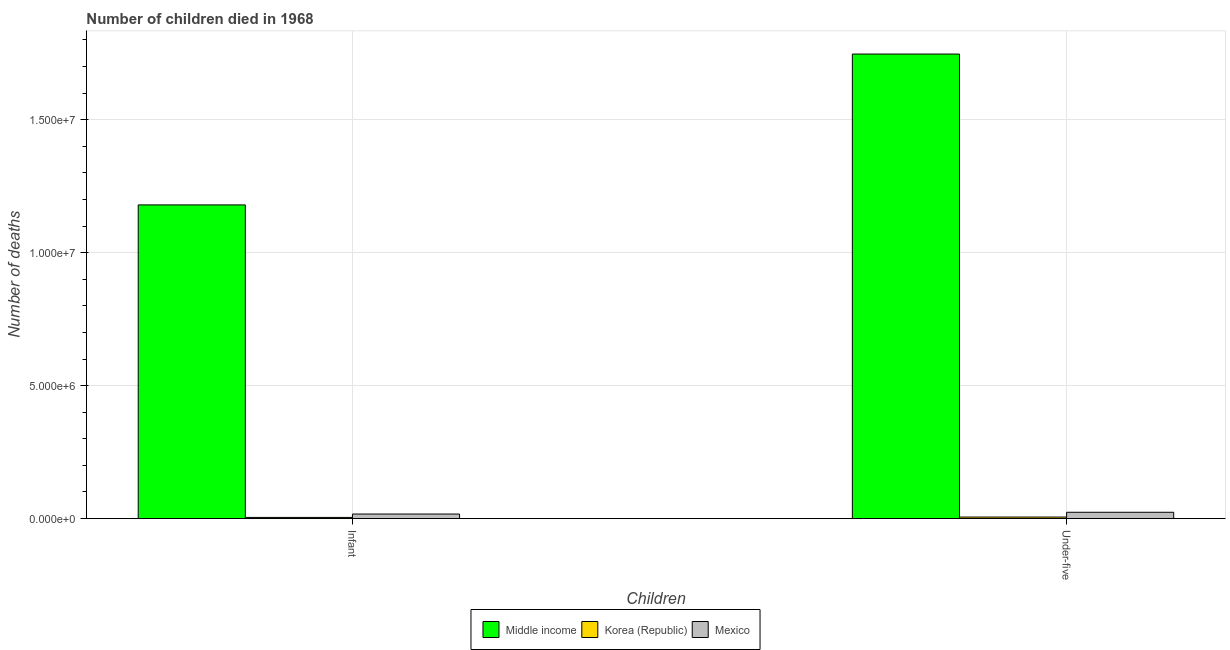Are the number of bars per tick equal to the number of legend labels?
Your answer should be very brief. Yes. How many bars are there on the 1st tick from the left?
Keep it short and to the point. 3. How many bars are there on the 2nd tick from the right?
Your answer should be compact. 3. What is the label of the 2nd group of bars from the left?
Make the answer very short. Under-five. What is the number of under-five deaths in Korea (Republic)?
Keep it short and to the point. 5.70e+04. Across all countries, what is the maximum number of infant deaths?
Give a very brief answer. 1.18e+07. Across all countries, what is the minimum number of infant deaths?
Offer a very short reply. 4.29e+04. In which country was the number of under-five deaths maximum?
Your answer should be very brief. Middle income. What is the total number of under-five deaths in the graph?
Ensure brevity in your answer.  1.78e+07. What is the difference between the number of infant deaths in Korea (Republic) and that in Mexico?
Your answer should be compact. -1.28e+05. What is the difference between the number of under-five deaths in Mexico and the number of infant deaths in Middle income?
Give a very brief answer. -1.16e+07. What is the average number of infant deaths per country?
Your answer should be very brief. 4.00e+06. What is the difference between the number of under-five deaths and number of infant deaths in Middle income?
Your response must be concise. 5.67e+06. In how many countries, is the number of under-five deaths greater than 8000000 ?
Ensure brevity in your answer.  1. What is the ratio of the number of under-five deaths in Mexico to that in Middle income?
Give a very brief answer. 0.01. What does the 3rd bar from the right in Under-five represents?
Keep it short and to the point. Middle income. How many bars are there?
Ensure brevity in your answer.  6. How many countries are there in the graph?
Give a very brief answer. 3. What is the difference between two consecutive major ticks on the Y-axis?
Offer a terse response. 5.00e+06. Does the graph contain any zero values?
Your response must be concise. No. How many legend labels are there?
Provide a short and direct response. 3. How are the legend labels stacked?
Offer a very short reply. Horizontal. What is the title of the graph?
Offer a very short reply. Number of children died in 1968. Does "Austria" appear as one of the legend labels in the graph?
Offer a very short reply. No. What is the label or title of the X-axis?
Provide a short and direct response. Children. What is the label or title of the Y-axis?
Ensure brevity in your answer.  Number of deaths. What is the Number of deaths of Middle income in Infant?
Your response must be concise. 1.18e+07. What is the Number of deaths in Korea (Republic) in Infant?
Your answer should be very brief. 4.29e+04. What is the Number of deaths of Mexico in Infant?
Keep it short and to the point. 1.70e+05. What is the Number of deaths in Middle income in Under-five?
Your answer should be compact. 1.75e+07. What is the Number of deaths of Korea (Republic) in Under-five?
Keep it short and to the point. 5.70e+04. What is the Number of deaths of Mexico in Under-five?
Keep it short and to the point. 2.36e+05. Across all Children, what is the maximum Number of deaths in Middle income?
Make the answer very short. 1.75e+07. Across all Children, what is the maximum Number of deaths in Korea (Republic)?
Provide a short and direct response. 5.70e+04. Across all Children, what is the maximum Number of deaths of Mexico?
Keep it short and to the point. 2.36e+05. Across all Children, what is the minimum Number of deaths of Middle income?
Provide a succinct answer. 1.18e+07. Across all Children, what is the minimum Number of deaths of Korea (Republic)?
Keep it short and to the point. 4.29e+04. Across all Children, what is the minimum Number of deaths of Mexico?
Your response must be concise. 1.70e+05. What is the total Number of deaths of Middle income in the graph?
Ensure brevity in your answer.  2.93e+07. What is the total Number of deaths of Korea (Republic) in the graph?
Your response must be concise. 1.00e+05. What is the total Number of deaths of Mexico in the graph?
Your answer should be very brief. 4.07e+05. What is the difference between the Number of deaths in Middle income in Infant and that in Under-five?
Your answer should be very brief. -5.67e+06. What is the difference between the Number of deaths of Korea (Republic) in Infant and that in Under-five?
Offer a very short reply. -1.41e+04. What is the difference between the Number of deaths in Mexico in Infant and that in Under-five?
Make the answer very short. -6.59e+04. What is the difference between the Number of deaths of Middle income in Infant and the Number of deaths of Korea (Republic) in Under-five?
Give a very brief answer. 1.17e+07. What is the difference between the Number of deaths in Middle income in Infant and the Number of deaths in Mexico in Under-five?
Provide a succinct answer. 1.16e+07. What is the difference between the Number of deaths in Korea (Republic) in Infant and the Number of deaths in Mexico in Under-five?
Provide a short and direct response. -1.93e+05. What is the average Number of deaths of Middle income per Children?
Keep it short and to the point. 1.46e+07. What is the average Number of deaths of Korea (Republic) per Children?
Ensure brevity in your answer.  5.00e+04. What is the average Number of deaths of Mexico per Children?
Provide a short and direct response. 2.03e+05. What is the difference between the Number of deaths in Middle income and Number of deaths in Korea (Republic) in Infant?
Your answer should be compact. 1.18e+07. What is the difference between the Number of deaths of Middle income and Number of deaths of Mexico in Infant?
Ensure brevity in your answer.  1.16e+07. What is the difference between the Number of deaths in Korea (Republic) and Number of deaths in Mexico in Infant?
Your response must be concise. -1.28e+05. What is the difference between the Number of deaths in Middle income and Number of deaths in Korea (Republic) in Under-five?
Keep it short and to the point. 1.74e+07. What is the difference between the Number of deaths in Middle income and Number of deaths in Mexico in Under-five?
Offer a terse response. 1.72e+07. What is the difference between the Number of deaths of Korea (Republic) and Number of deaths of Mexico in Under-five?
Provide a short and direct response. -1.79e+05. What is the ratio of the Number of deaths of Middle income in Infant to that in Under-five?
Offer a very short reply. 0.68. What is the ratio of the Number of deaths of Korea (Republic) in Infant to that in Under-five?
Make the answer very short. 0.75. What is the ratio of the Number of deaths of Mexico in Infant to that in Under-five?
Ensure brevity in your answer.  0.72. What is the difference between the highest and the second highest Number of deaths of Middle income?
Keep it short and to the point. 5.67e+06. What is the difference between the highest and the second highest Number of deaths in Korea (Republic)?
Keep it short and to the point. 1.41e+04. What is the difference between the highest and the second highest Number of deaths of Mexico?
Offer a terse response. 6.59e+04. What is the difference between the highest and the lowest Number of deaths in Middle income?
Your answer should be compact. 5.67e+06. What is the difference between the highest and the lowest Number of deaths in Korea (Republic)?
Provide a succinct answer. 1.41e+04. What is the difference between the highest and the lowest Number of deaths of Mexico?
Your answer should be very brief. 6.59e+04. 